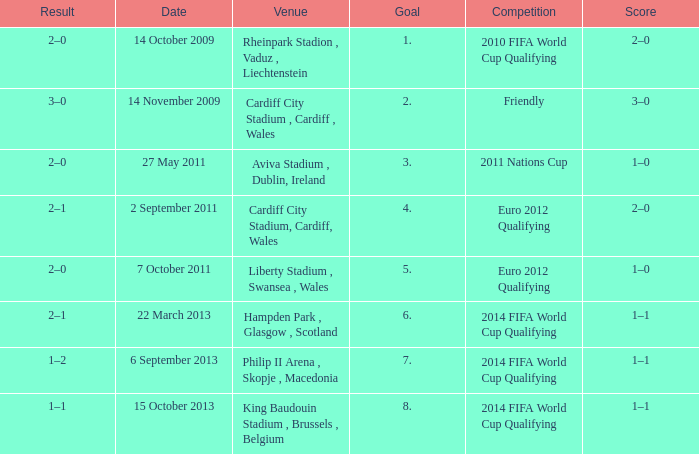What is the Venue for Goal number 1? Rheinpark Stadion , Vaduz , Liechtenstein. 